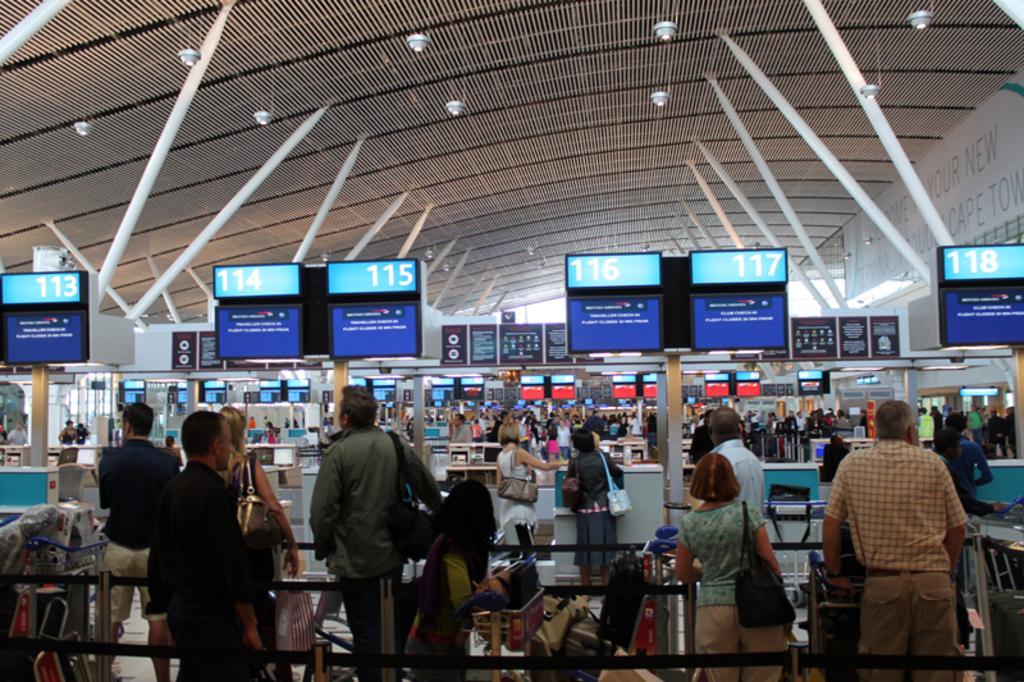Could you give a brief overview of what you see in this image? In this image there are group of people standing at the table. In the foreground there is a railing. At the back there are poles and there are boards on the poles. There is a text on the boards. At the top there are lights and there is a banner and there is a text on the banner. 